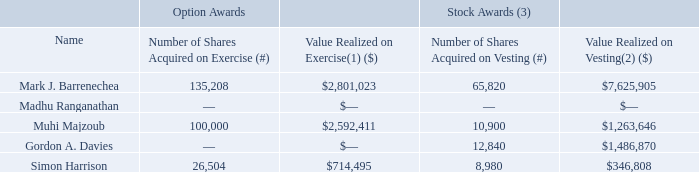Option Exercises and Stock Vested in Fiscal 2019
The following table sets forth certain details with respect to each of the Named Executive Officers concerning the exercise of stock options and vesting of stock in Fiscal 2019:
(1) “Value realized on exercise” is the excess of the market price, at date of exercise, of the shares underlying the options over the exercise price of the options.
(2) “Value realized on vesting” is the market price of the underlying Common Shares on the vesting date.
(3) Relates to the vesting of PSUs and RSUs under our Fiscal 2018 LTIP.
What does this table represent? Certain details with respect to each of the named executive officers concerning the exercise of stock options and vesting of stock in fiscal 2019. What is  “Value realized on exercise”? The excess of the market price, at date of exercise, of the shares underlying the options over the exercise price of the options. What is the Number of Shares Acquired on Exercise (#) for Simon Harrison? 26,504. What is the Value Realized on Vesting of Mark J. Barrenechea expressed as a percentage of total Value Realized on Vesting?
Answer scale should be: percent. 7,625,905/(7,625,905+1,263,646+1,486,870+346,808)
Answer: 71.12. For Simon Harrison, what is the average value of each share aquired on vesting? 346,808/8,980
Answer: 38.62. What is the Total Value Realized on Exercise? 2,801,023+2,592,411+714,495
Answer: 6107929. 